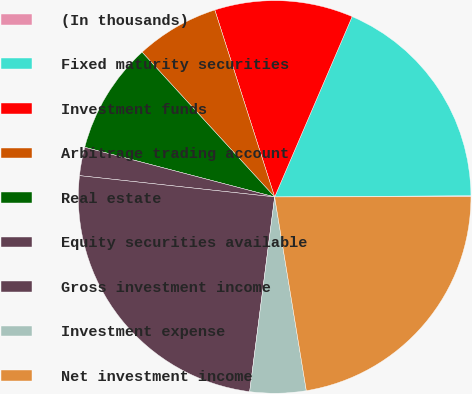<chart> <loc_0><loc_0><loc_500><loc_500><pie_chart><fcel>(In thousands)<fcel>Fixed maturity securities<fcel>Investment funds<fcel>Arbitrage trading account<fcel>Real estate<fcel>Equity securities available<fcel>Gross investment income<fcel>Investment expense<fcel>Net investment income<nl><fcel>0.08%<fcel>18.44%<fcel>11.39%<fcel>6.87%<fcel>9.13%<fcel>2.34%<fcel>24.7%<fcel>4.61%<fcel>22.44%<nl></chart> 